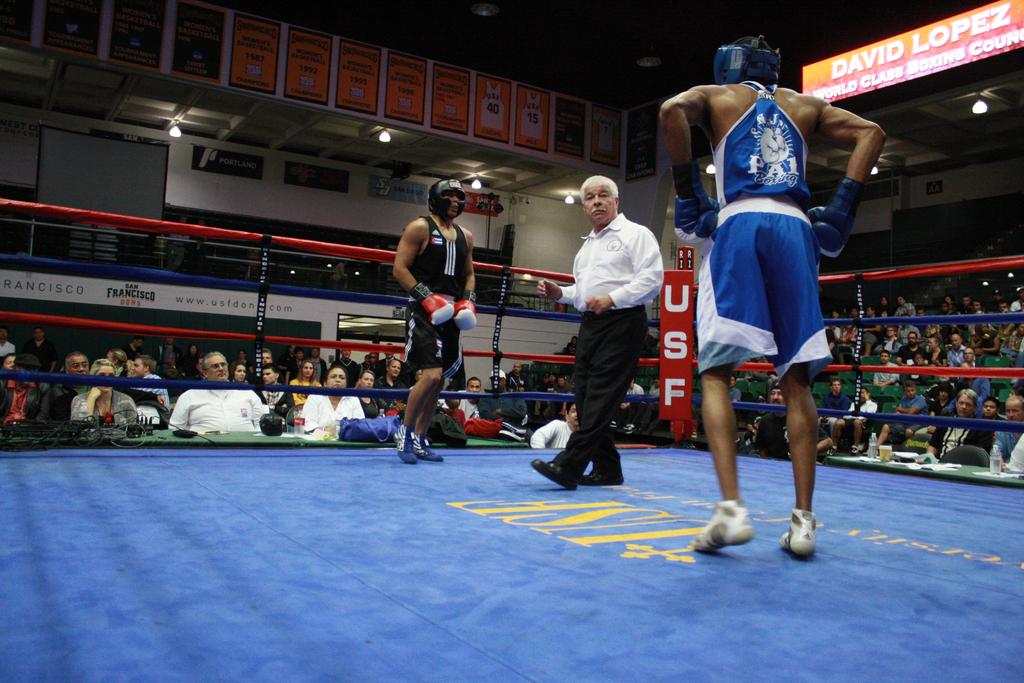What type of fight is this?
Offer a terse response. Boxing. 